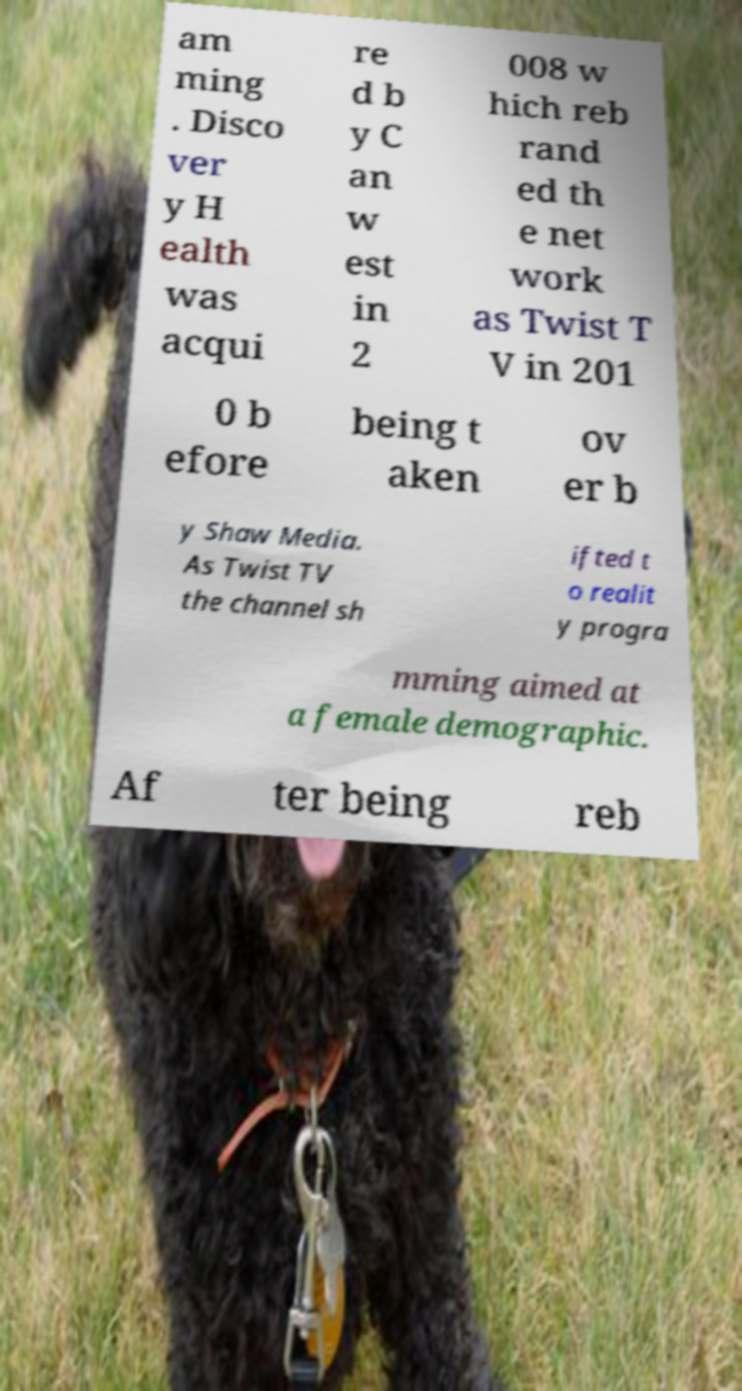Please identify and transcribe the text found in this image. am ming . Disco ver y H ealth was acqui re d b y C an w est in 2 008 w hich reb rand ed th e net work as Twist T V in 201 0 b efore being t aken ov er b y Shaw Media. As Twist TV the channel sh ifted t o realit y progra mming aimed at a female demographic. Af ter being reb 